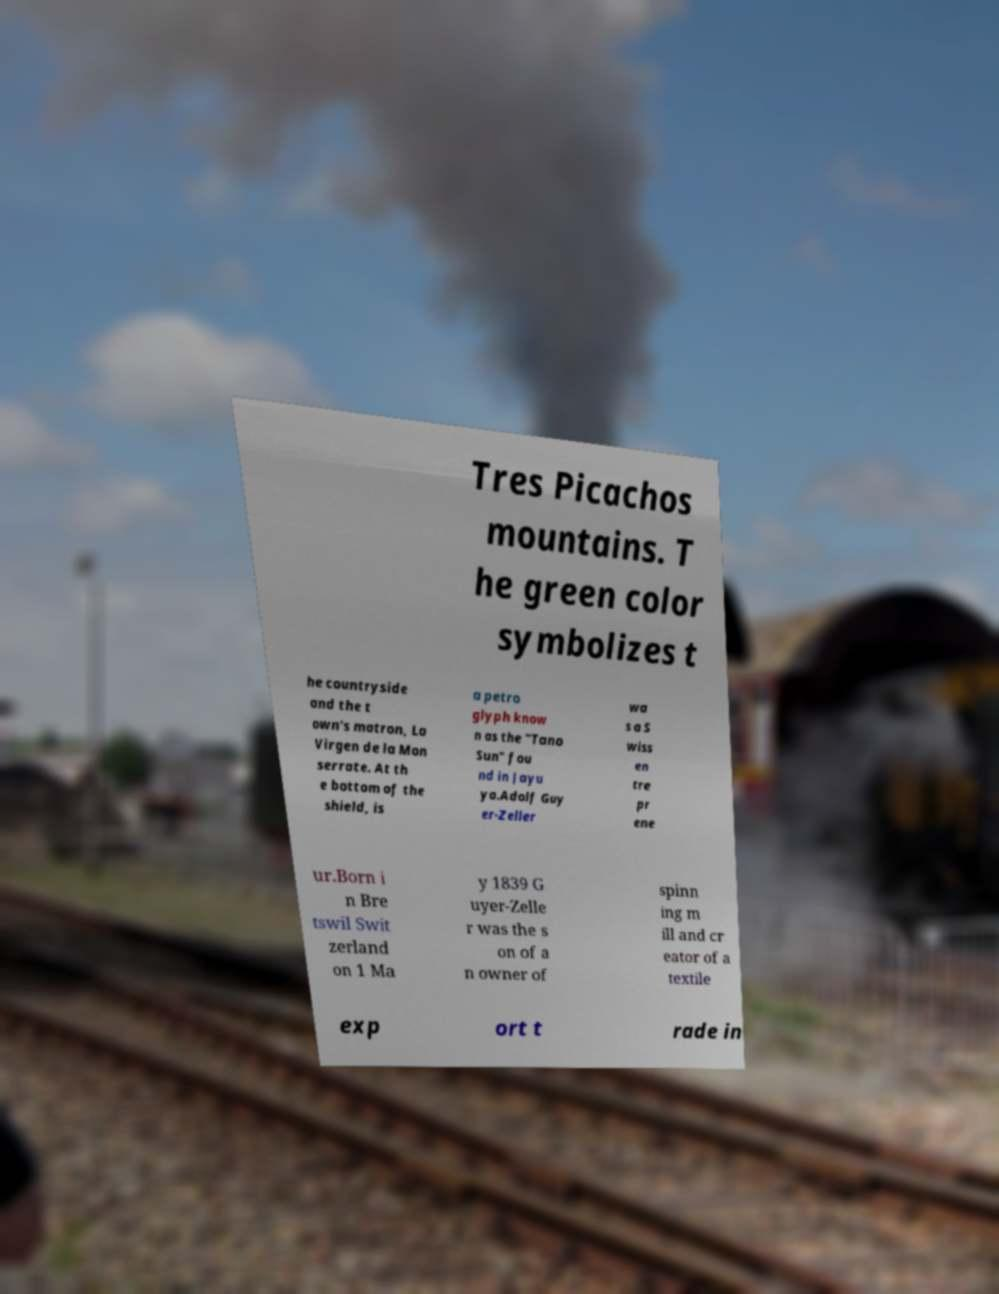Please read and relay the text visible in this image. What does it say? Tres Picachos mountains. T he green color symbolizes t he countryside and the t own's matron, La Virgen de la Mon serrate. At th e bottom of the shield, is a petro glyph know n as the "Tano Sun" fou nd in Jayu ya.Adolf Guy er-Zeller wa s a S wiss en tre pr ene ur.Born i n Bre tswil Swit zerland on 1 Ma y 1839 G uyer-Zelle r was the s on of a n owner of spinn ing m ill and cr eator of a textile exp ort t rade in 